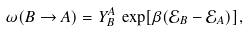Convert formula to latex. <formula><loc_0><loc_0><loc_500><loc_500>\omega ( B \to A ) = Y ^ { A } _ { B } \, \exp [ \beta ( \mathcal { E } _ { B } - \mathcal { E } _ { A } ) ] ,</formula> 